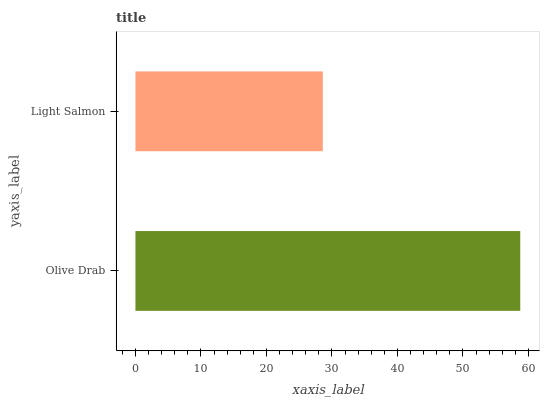Is Light Salmon the minimum?
Answer yes or no. Yes. Is Olive Drab the maximum?
Answer yes or no. Yes. Is Light Salmon the maximum?
Answer yes or no. No. Is Olive Drab greater than Light Salmon?
Answer yes or no. Yes. Is Light Salmon less than Olive Drab?
Answer yes or no. Yes. Is Light Salmon greater than Olive Drab?
Answer yes or no. No. Is Olive Drab less than Light Salmon?
Answer yes or no. No. Is Olive Drab the high median?
Answer yes or no. Yes. Is Light Salmon the low median?
Answer yes or no. Yes. Is Light Salmon the high median?
Answer yes or no. No. Is Olive Drab the low median?
Answer yes or no. No. 